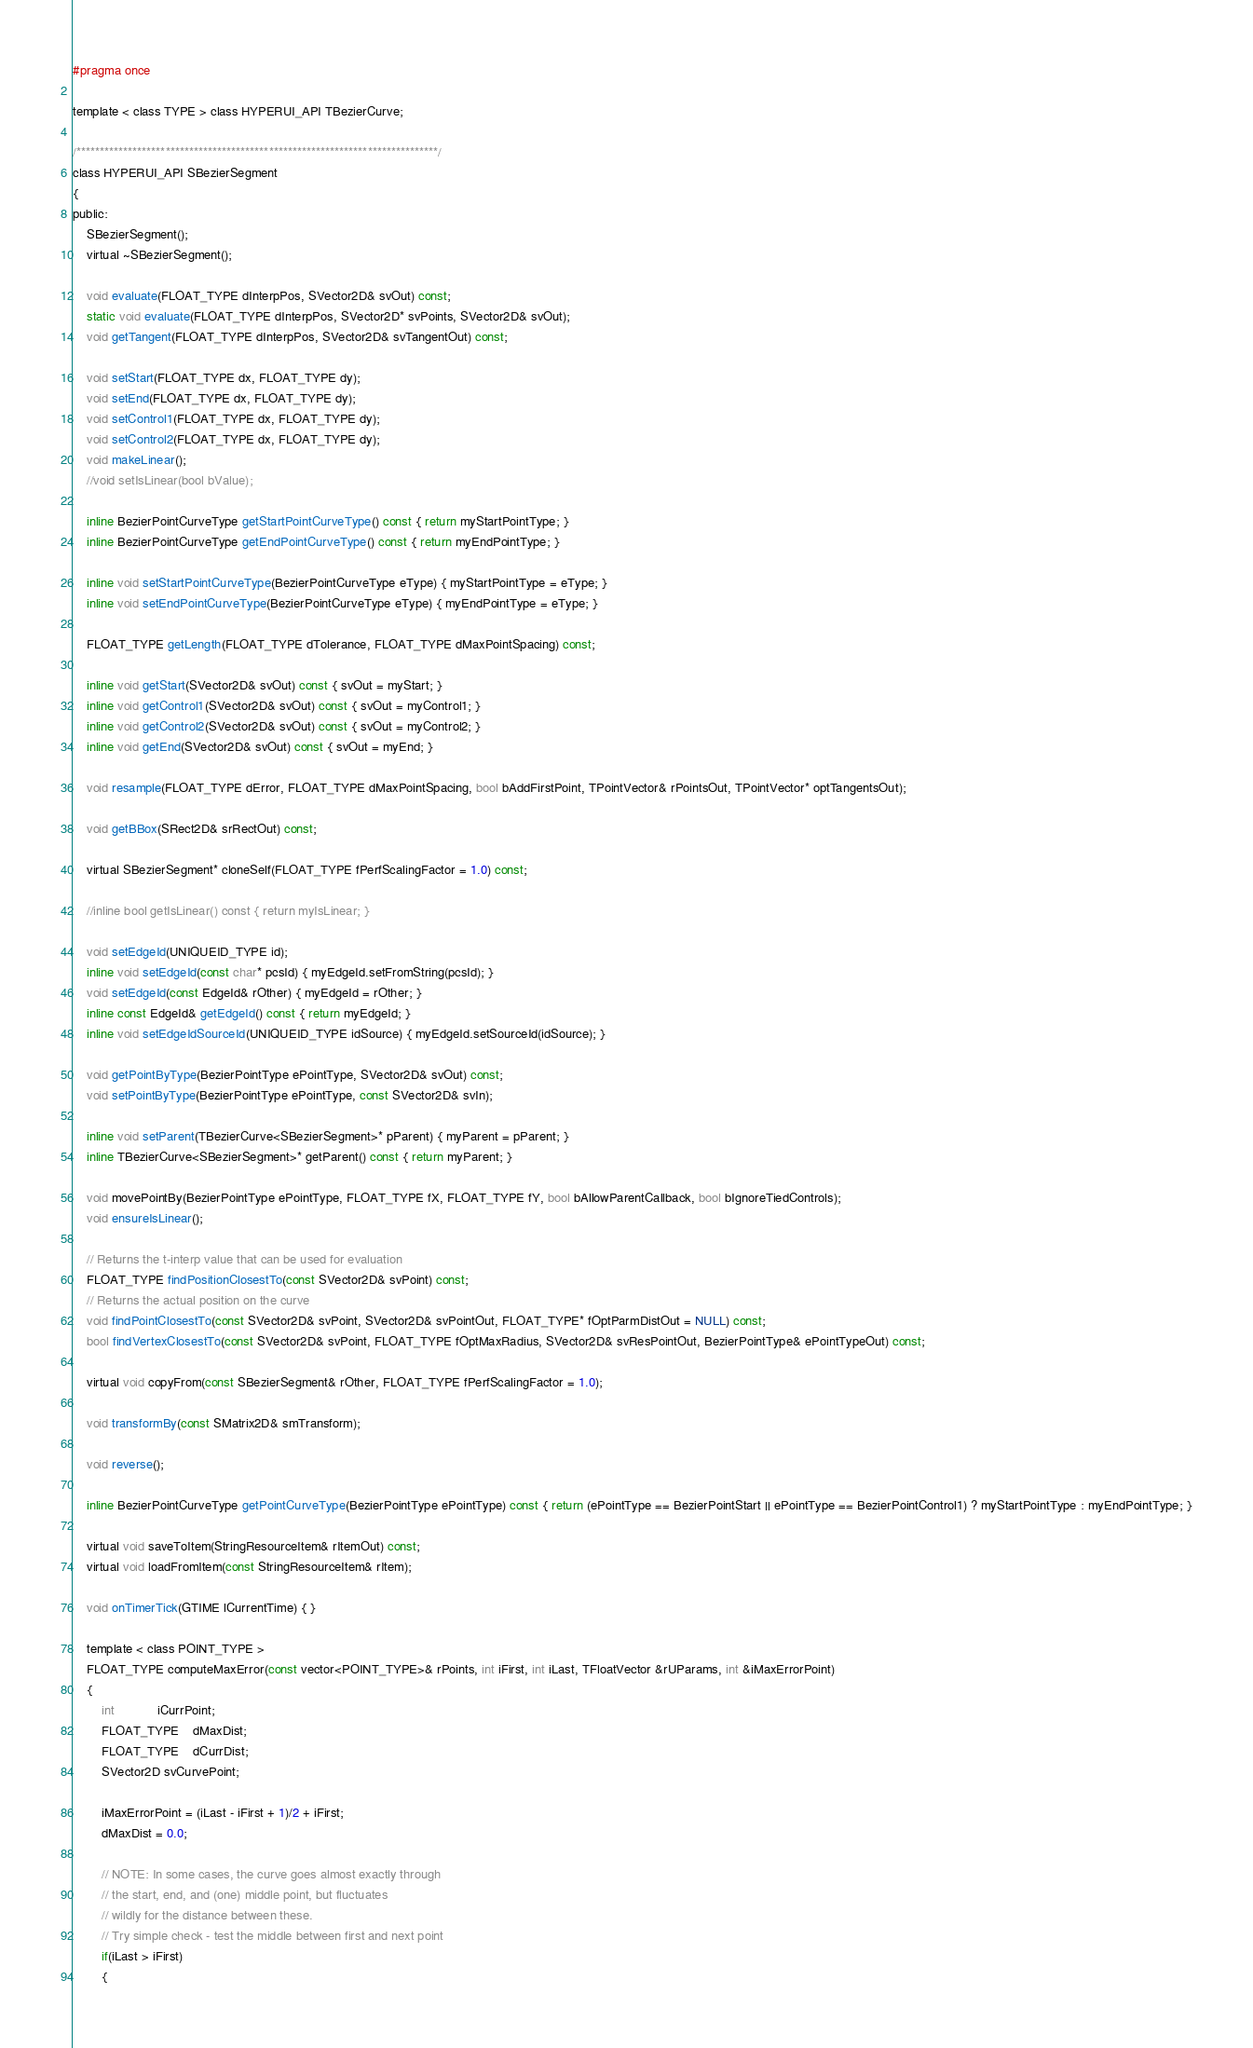Convert code to text. <code><loc_0><loc_0><loc_500><loc_500><_C_>#pragma once

template < class TYPE > class HYPERUI_API TBezierCurve;

/*****************************************************************************/
class HYPERUI_API SBezierSegment
{
public:
	SBezierSegment();
	virtual ~SBezierSegment();

	void evaluate(FLOAT_TYPE dInterpPos, SVector2D& svOut) const;
	static void evaluate(FLOAT_TYPE dInterpPos, SVector2D* svPoints, SVector2D& svOut);
	void getTangent(FLOAT_TYPE dInterpPos, SVector2D& svTangentOut) const;

	void setStart(FLOAT_TYPE dx, FLOAT_TYPE dy);
	void setEnd(FLOAT_TYPE dx, FLOAT_TYPE dy);
	void setControl1(FLOAT_TYPE dx, FLOAT_TYPE dy);
	void setControl2(FLOAT_TYPE dx, FLOAT_TYPE dy);
	void makeLinear();
	//void setIsLinear(bool bValue);

	inline BezierPointCurveType getStartPointCurveType() const { return myStartPointType; }
	inline BezierPointCurveType getEndPointCurveType() const { return myEndPointType; }

	inline void setStartPointCurveType(BezierPointCurveType eType) { myStartPointType = eType; }
	inline void setEndPointCurveType(BezierPointCurveType eType) { myEndPointType = eType; }

	FLOAT_TYPE getLength(FLOAT_TYPE dTolerance, FLOAT_TYPE dMaxPointSpacing) const;

	inline void getStart(SVector2D& svOut) const { svOut = myStart; }
	inline void getControl1(SVector2D& svOut) const { svOut = myControl1; }
	inline void getControl2(SVector2D& svOut) const { svOut = myControl2; }
	inline void getEnd(SVector2D& svOut) const { svOut = myEnd; }

	void resample(FLOAT_TYPE dError, FLOAT_TYPE dMaxPointSpacing, bool bAddFirstPoint, TPointVector& rPointsOut, TPointVector* optTangentsOut);

	void getBBox(SRect2D& srRectOut) const;

	virtual SBezierSegment* cloneSelf(FLOAT_TYPE fPerfScalingFactor = 1.0) const;

	//inline bool getIsLinear() const { return myIsLinear; }

	void setEdgeId(UNIQUEID_TYPE id);
	inline void setEdgeId(const char* pcsId) { myEdgeId.setFromString(pcsId); }
	void setEdgeId(const EdgeId& rOther) { myEdgeId = rOther; }
	inline const EdgeId& getEdgeId() const { return myEdgeId; }
	inline void setEdgeIdSourceId(UNIQUEID_TYPE idSource) { myEdgeId.setSourceId(idSource); }

	void getPointByType(BezierPointType ePointType, SVector2D& svOut) const;
	void setPointByType(BezierPointType ePointType, const SVector2D& svIn);

	inline void setParent(TBezierCurve<SBezierSegment>* pParent) { myParent = pParent; }
	inline TBezierCurve<SBezierSegment>* getParent() const { return myParent; }

	void movePointBy(BezierPointType ePointType, FLOAT_TYPE fX, FLOAT_TYPE fY, bool bAllowParentCallback, bool bIgnoreTiedControls);
	void ensureIsLinear();

	// Returns the t-interp value that can be used for evaluation
	FLOAT_TYPE findPositionClosestTo(const SVector2D& svPoint) const;
	// Returns the actual position on the curve
	void findPointClosestTo(const SVector2D& svPoint, SVector2D& svPointOut, FLOAT_TYPE* fOptParmDistOut = NULL) const;
	bool findVertexClosestTo(const SVector2D& svPoint, FLOAT_TYPE fOptMaxRadius, SVector2D& svResPointOut, BezierPointType& ePointTypeOut) const;

	virtual void copyFrom(const SBezierSegment& rOther, FLOAT_TYPE fPerfScalingFactor = 1.0);

	void transformBy(const SMatrix2D& smTransform);

	void reverse();

	inline BezierPointCurveType getPointCurveType(BezierPointType ePointType) const { return (ePointType == BezierPointStart || ePointType == BezierPointControl1) ? myStartPointType : myEndPointType; }

	virtual void saveToItem(StringResourceItem& rItemOut) const;
	virtual void loadFromItem(const StringResourceItem& rItem);

	void onTimerTick(GTIME lCurrentTime) { }

	template < class POINT_TYPE > 
	FLOAT_TYPE computeMaxError(const vector<POINT_TYPE>& rPoints, int iFirst, int iLast, TFloatVector &rUParams, int &iMaxErrorPoint)
	{
		int			iCurrPoint;
		FLOAT_TYPE	dMaxDist;		
		FLOAT_TYPE	dCurrDist;
		SVector2D svCurvePoint;

		iMaxErrorPoint = (iLast - iFirst + 1)/2 + iFirst;
		dMaxDist = 0.0;

		// NOTE: In some cases, the curve goes almost exactly through
		// the start, end, and (one) middle point, but fluctuates
		// wildly for the distance between these. 
		// Try simple check - test the middle between first and next point
		if(iLast > iFirst)
		{</code> 